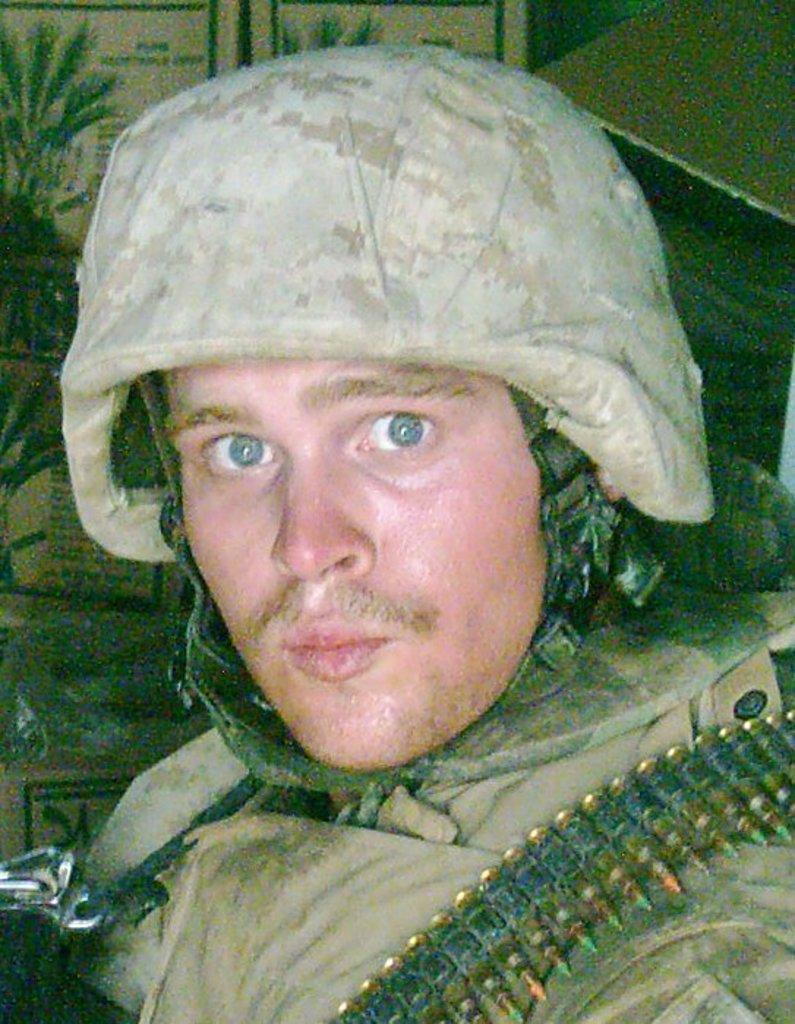What type of person is in the image? There is an army personnel in the image. What can be seen on the army personnel's shoulder? The army personnel has bullets on his shoulder. What is located behind the army personnel? There are cardboard boxes behind the army personnel. Can you tell me how many basketballs are visible in the image? There are no basketballs present in the image. What type of brush is being used by the army personnel in the image? There is no brush visible in the image. 